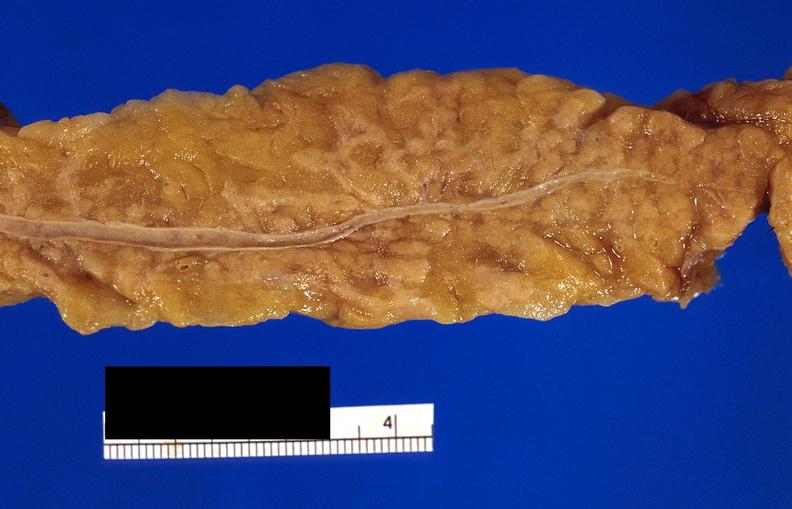what does this image show?
Answer the question using a single word or phrase. Pancreatic fat necrosis 